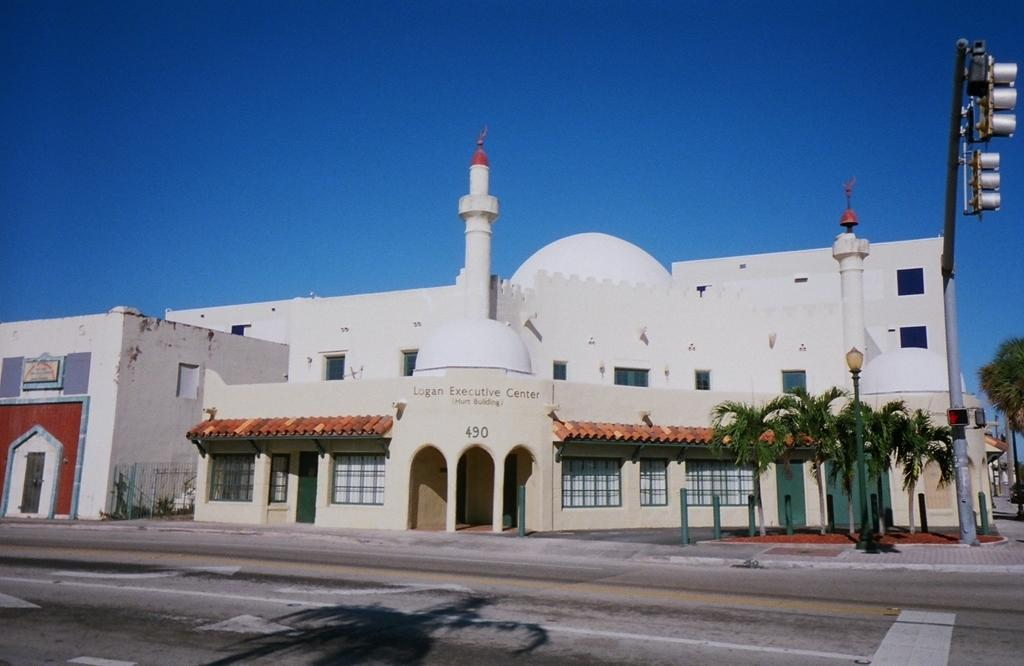What is the main structure in the center of the image? There is a mosque in the center of the image. What type of vegetation can be seen in the image? There are trees in the image. What objects are present to support or guide in the image? There are poles in the image. What can be used for illumination in the image? There are lights in the image. What is the pathway for people to walk on in the image? There is a walkway at the bottom of the image. What is visible at the top of the image? The sky is visible at the top of the image. Where is the mailbox located in the image? There is no mailbox present in the image. What does the tongue of the person in the image look like? There are no people or tongues visible in the image. How many times do the people in the image kiss each other? There are no people or kissing depicted in the image. 